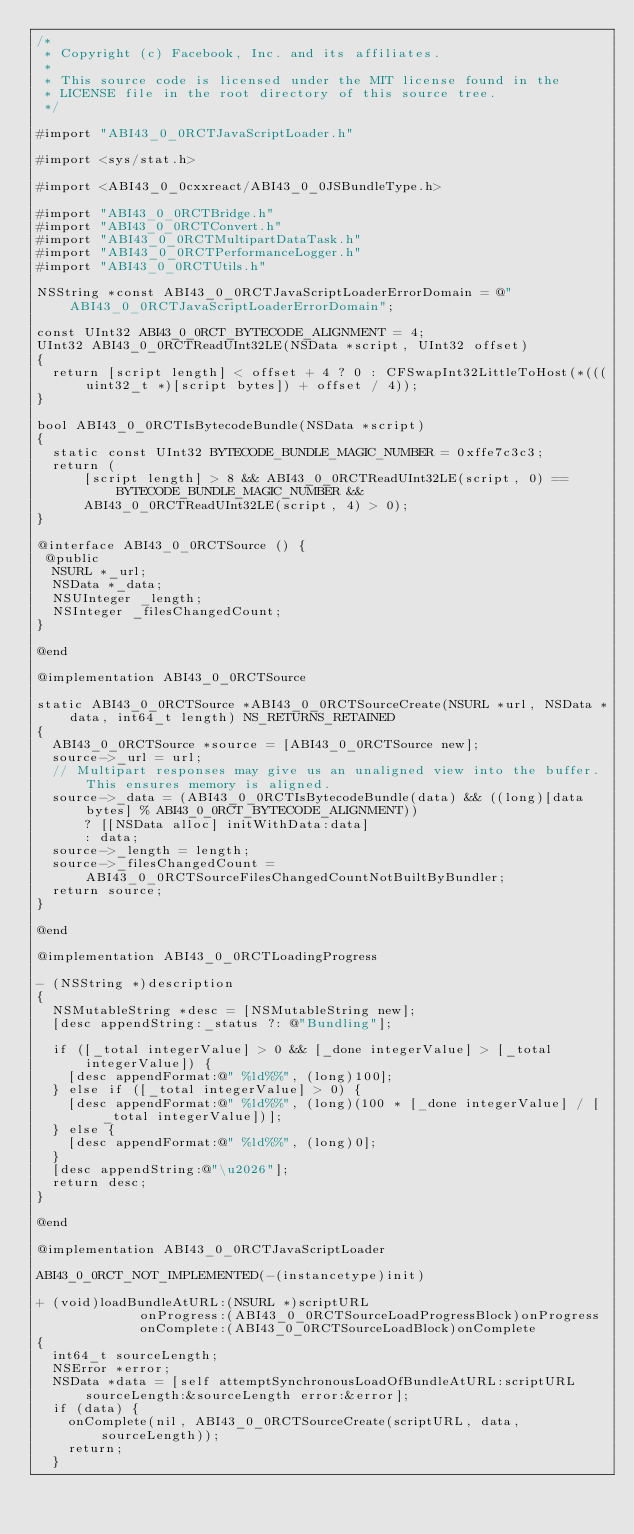Convert code to text. <code><loc_0><loc_0><loc_500><loc_500><_ObjectiveC_>/*
 * Copyright (c) Facebook, Inc. and its affiliates.
 *
 * This source code is licensed under the MIT license found in the
 * LICENSE file in the root directory of this source tree.
 */

#import "ABI43_0_0RCTJavaScriptLoader.h"

#import <sys/stat.h>

#import <ABI43_0_0cxxreact/ABI43_0_0JSBundleType.h>

#import "ABI43_0_0RCTBridge.h"
#import "ABI43_0_0RCTConvert.h"
#import "ABI43_0_0RCTMultipartDataTask.h"
#import "ABI43_0_0RCTPerformanceLogger.h"
#import "ABI43_0_0RCTUtils.h"

NSString *const ABI43_0_0RCTJavaScriptLoaderErrorDomain = @"ABI43_0_0RCTJavaScriptLoaderErrorDomain";

const UInt32 ABI43_0_0RCT_BYTECODE_ALIGNMENT = 4;
UInt32 ABI43_0_0RCTReadUInt32LE(NSData *script, UInt32 offset)
{
  return [script length] < offset + 4 ? 0 : CFSwapInt32LittleToHost(*(((uint32_t *)[script bytes]) + offset / 4));
}

bool ABI43_0_0RCTIsBytecodeBundle(NSData *script)
{
  static const UInt32 BYTECODE_BUNDLE_MAGIC_NUMBER = 0xffe7c3c3;
  return (
      [script length] > 8 && ABI43_0_0RCTReadUInt32LE(script, 0) == BYTECODE_BUNDLE_MAGIC_NUMBER &&
      ABI43_0_0RCTReadUInt32LE(script, 4) > 0);
}

@interface ABI43_0_0RCTSource () {
 @public
  NSURL *_url;
  NSData *_data;
  NSUInteger _length;
  NSInteger _filesChangedCount;
}

@end

@implementation ABI43_0_0RCTSource

static ABI43_0_0RCTSource *ABI43_0_0RCTSourceCreate(NSURL *url, NSData *data, int64_t length) NS_RETURNS_RETAINED
{
  ABI43_0_0RCTSource *source = [ABI43_0_0RCTSource new];
  source->_url = url;
  // Multipart responses may give us an unaligned view into the buffer. This ensures memory is aligned.
  source->_data = (ABI43_0_0RCTIsBytecodeBundle(data) && ((long)[data bytes] % ABI43_0_0RCT_BYTECODE_ALIGNMENT))
      ? [[NSData alloc] initWithData:data]
      : data;
  source->_length = length;
  source->_filesChangedCount = ABI43_0_0RCTSourceFilesChangedCountNotBuiltByBundler;
  return source;
}

@end

@implementation ABI43_0_0RCTLoadingProgress

- (NSString *)description
{
  NSMutableString *desc = [NSMutableString new];
  [desc appendString:_status ?: @"Bundling"];

  if ([_total integerValue] > 0 && [_done integerValue] > [_total integerValue]) {
    [desc appendFormat:@" %ld%%", (long)100];
  } else if ([_total integerValue] > 0) {
    [desc appendFormat:@" %ld%%", (long)(100 * [_done integerValue] / [_total integerValue])];
  } else {
    [desc appendFormat:@" %ld%%", (long)0];
  }
  [desc appendString:@"\u2026"];
  return desc;
}

@end

@implementation ABI43_0_0RCTJavaScriptLoader

ABI43_0_0RCT_NOT_IMPLEMENTED(-(instancetype)init)

+ (void)loadBundleAtURL:(NSURL *)scriptURL
             onProgress:(ABI43_0_0RCTSourceLoadProgressBlock)onProgress
             onComplete:(ABI43_0_0RCTSourceLoadBlock)onComplete
{
  int64_t sourceLength;
  NSError *error;
  NSData *data = [self attemptSynchronousLoadOfBundleAtURL:scriptURL sourceLength:&sourceLength error:&error];
  if (data) {
    onComplete(nil, ABI43_0_0RCTSourceCreate(scriptURL, data, sourceLength));
    return;
  }
</code> 